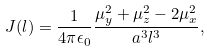Convert formula to latex. <formula><loc_0><loc_0><loc_500><loc_500>J ( l ) = \frac { 1 } { 4 \pi \epsilon _ { 0 } } \frac { \mu _ { y } ^ { 2 } + \mu _ { z } ^ { 2 } - 2 \mu _ { x } ^ { 2 } } { a ^ { 3 } l ^ { 3 } } ,</formula> 